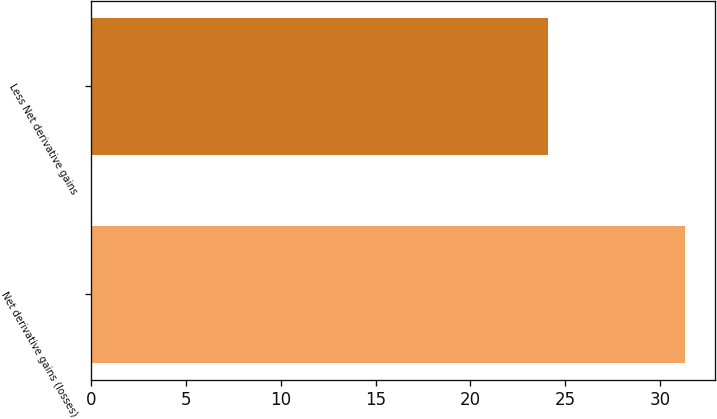<chart> <loc_0><loc_0><loc_500><loc_500><bar_chart><fcel>Net derivative gains (losses)<fcel>Less Net derivative gains<nl><fcel>31.31<fcel>24.1<nl></chart> 